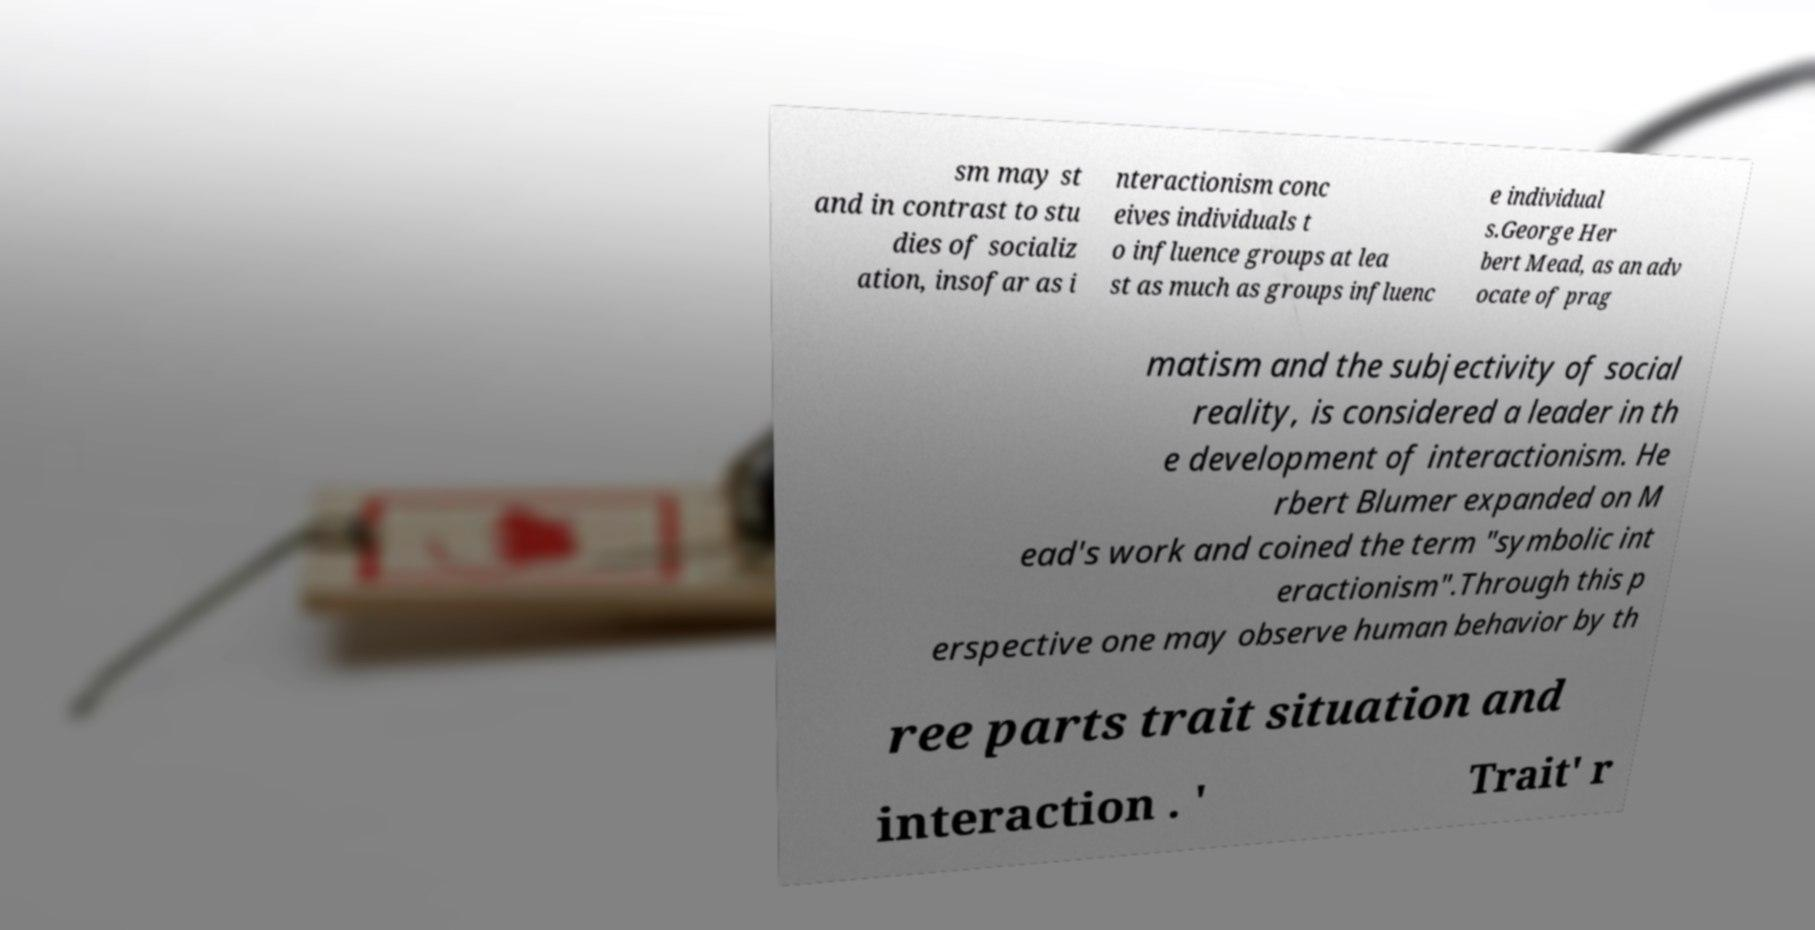Can you read and provide the text displayed in the image?This photo seems to have some interesting text. Can you extract and type it out for me? sm may st and in contrast to stu dies of socializ ation, insofar as i nteractionism conc eives individuals t o influence groups at lea st as much as groups influenc e individual s.George Her bert Mead, as an adv ocate of prag matism and the subjectivity of social reality, is considered a leader in th e development of interactionism. He rbert Blumer expanded on M ead's work and coined the term "symbolic int eractionism".Through this p erspective one may observe human behavior by th ree parts trait situation and interaction . ' Trait' r 